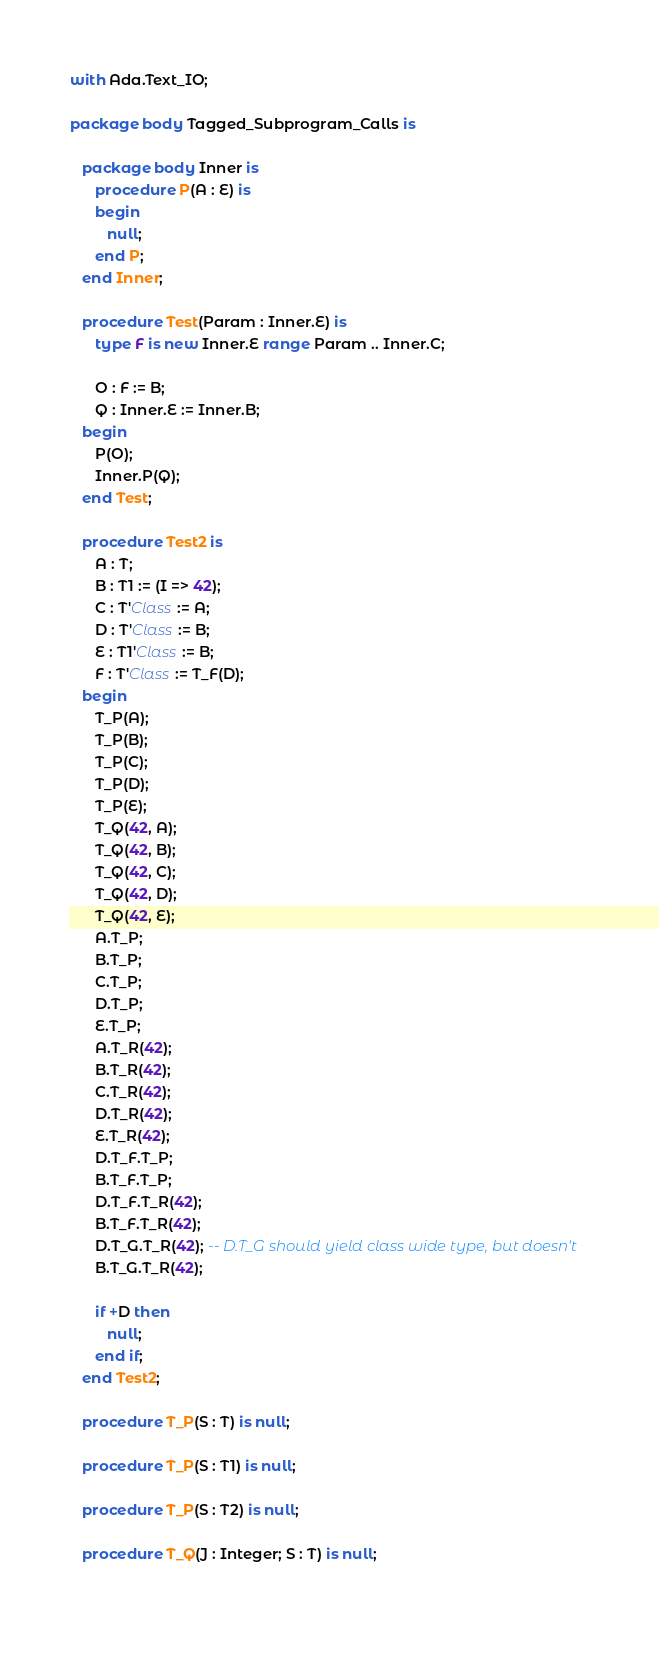<code> <loc_0><loc_0><loc_500><loc_500><_Ada_>with Ada.Text_IO;

package body Tagged_Subprogram_Calls is

   package body Inner is
      procedure P(A : E) is
      begin
         null;
      end P;
   end Inner;         

   procedure Test(Param : Inner.E) is
      type F is new Inner.E range Param .. Inner.C;
      
      O : F := B;
      Q : Inner.E := Inner.B;
   begin
      P(O);
      Inner.P(Q);
   end Test;
      
   procedure Test2 is
      A : T;
      B : T1 := (I => 42);
      C : T'Class := A;
      D : T'Class := B;
      E : T1'Class := B;
      F : T'Class := T_F(D);
   begin
      T_P(A);
      T_P(B);
      T_P(C);
      T_P(D);
      T_P(E);
      T_Q(42, A);
      T_Q(42, B);
      T_Q(42, C);
      T_Q(42, D);
      T_Q(42, E);
      A.T_P;
      B.T_P;
      C.T_P;
      D.T_P;
      E.T_P;
      A.T_R(42);
      B.T_R(42);
      C.T_R(42);
      D.T_R(42);
      E.T_R(42);
      D.T_F.T_P;
      B.T_F.T_P;
      D.T_F.T_R(42);
      B.T_F.T_R(42);
      D.T_G.T_R(42); -- D.T_G should yield class wide type, but doesn't
      B.T_G.T_R(42);
      
      if +D then
         null;
      end if;
   end Test2;

   procedure T_P(S : T) is null;
   
   procedure T_P(S : T1) is null;

   procedure T_P(S : T2) is null;

   procedure T_Q(J : Integer; S : T) is null;
   </code> 